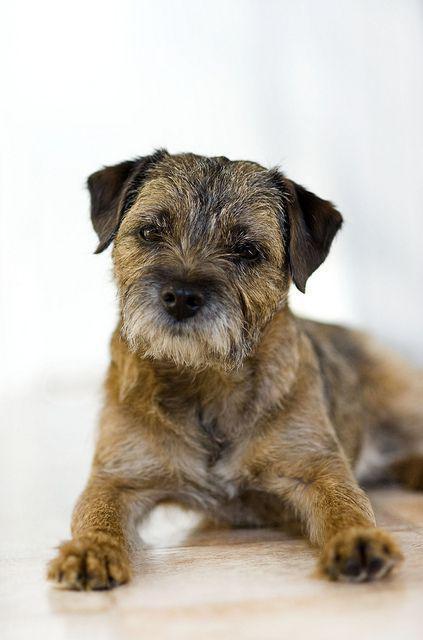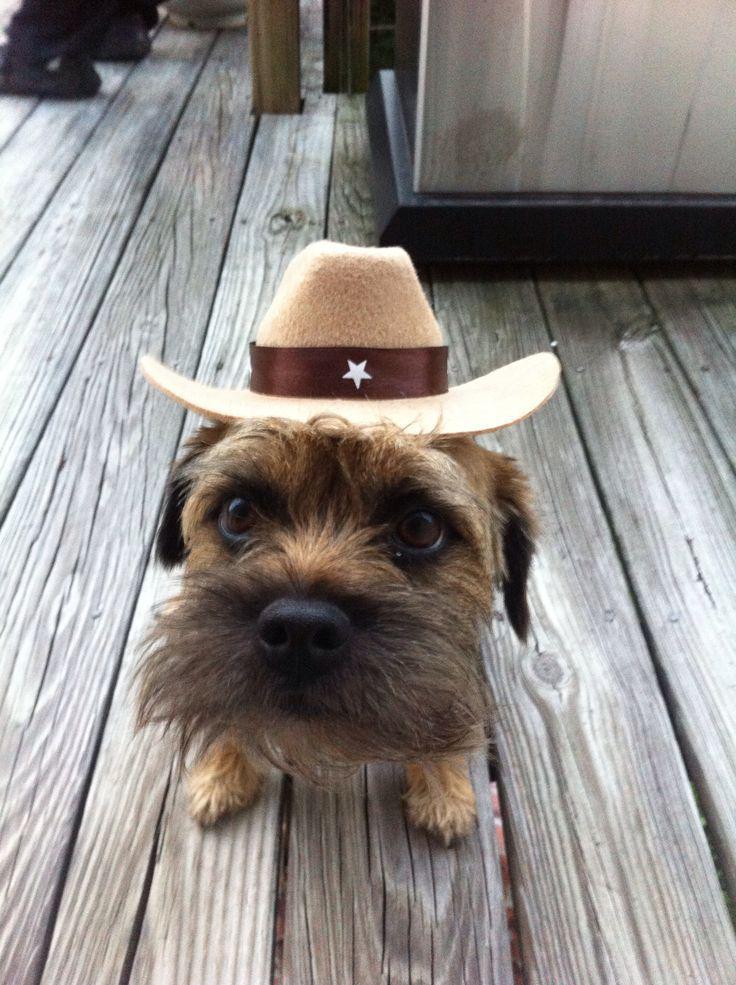The first image is the image on the left, the second image is the image on the right. Examine the images to the left and right. Is the description "None of the dogs' tongues are visible." accurate? Answer yes or no. Yes. 